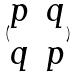<formula> <loc_0><loc_0><loc_500><loc_500>( \begin{matrix} p & q \\ q & p \end{matrix} )</formula> 